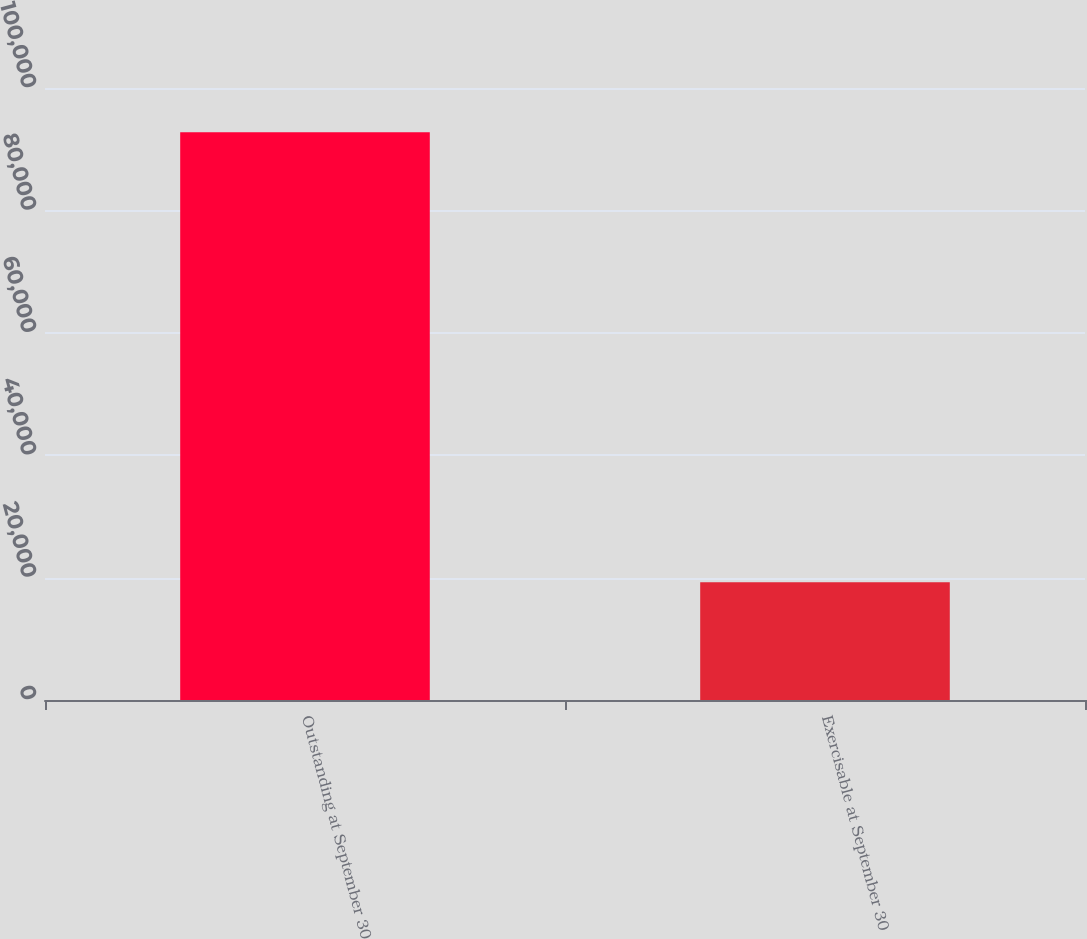Convert chart. <chart><loc_0><loc_0><loc_500><loc_500><bar_chart><fcel>Outstanding at September 30<fcel>Exercisable at September 30<nl><fcel>92762<fcel>19246<nl></chart> 